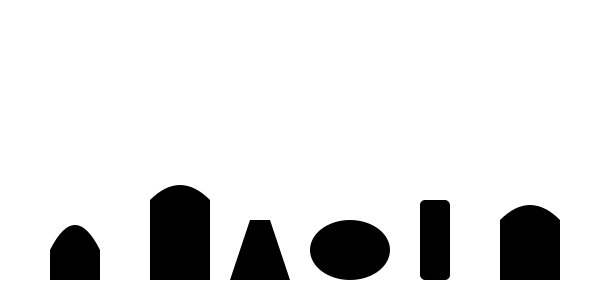As a country music radio DJ, you're always on the lookout for authentic instruments in new tracks. Identify the instrument that is NOT typically associated with traditional country music from the silhouettes shown above. Let's analyze each instrument silhouette:

1. The first silhouette represents a guitar, a staple in country music.
2. The second shape depicts a banjo, another classic country instrument.
3. The third silhouette shows a fiddle (violin), essential in country music.
4. The fourth shape is a harmonica, commonly used in country songs.
5. The fifth silhouette represents an upright bass, often seen in country bands.
6. The last shape depicts a mandolin, which has a long history in country and bluegrass music.

Among these instruments, all are traditionally associated with country music. However, the harmonica, while used in country music, is more commonly associated with blues and folk genres. It's the least "typically country" instrument in this lineup.
Answer: Harmonica 